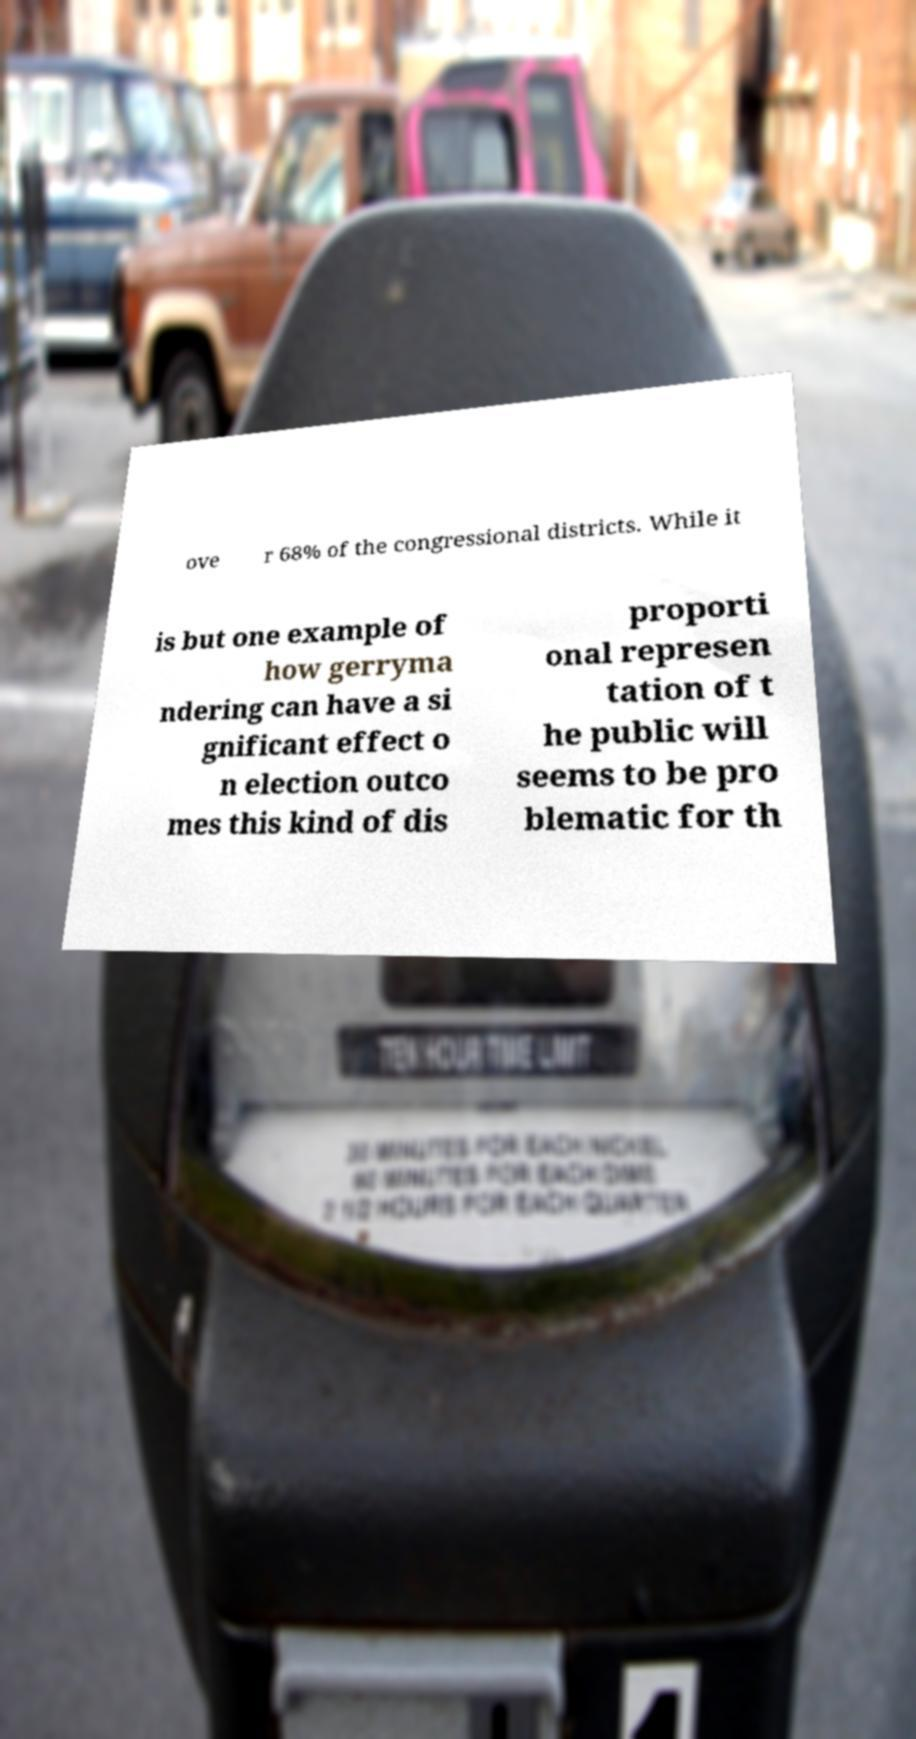Please read and relay the text visible in this image. What does it say? ove r 68% of the congressional districts. While it is but one example of how gerryma ndering can have a si gnificant effect o n election outco mes this kind of dis proporti onal represen tation of t he public will seems to be pro blematic for th 